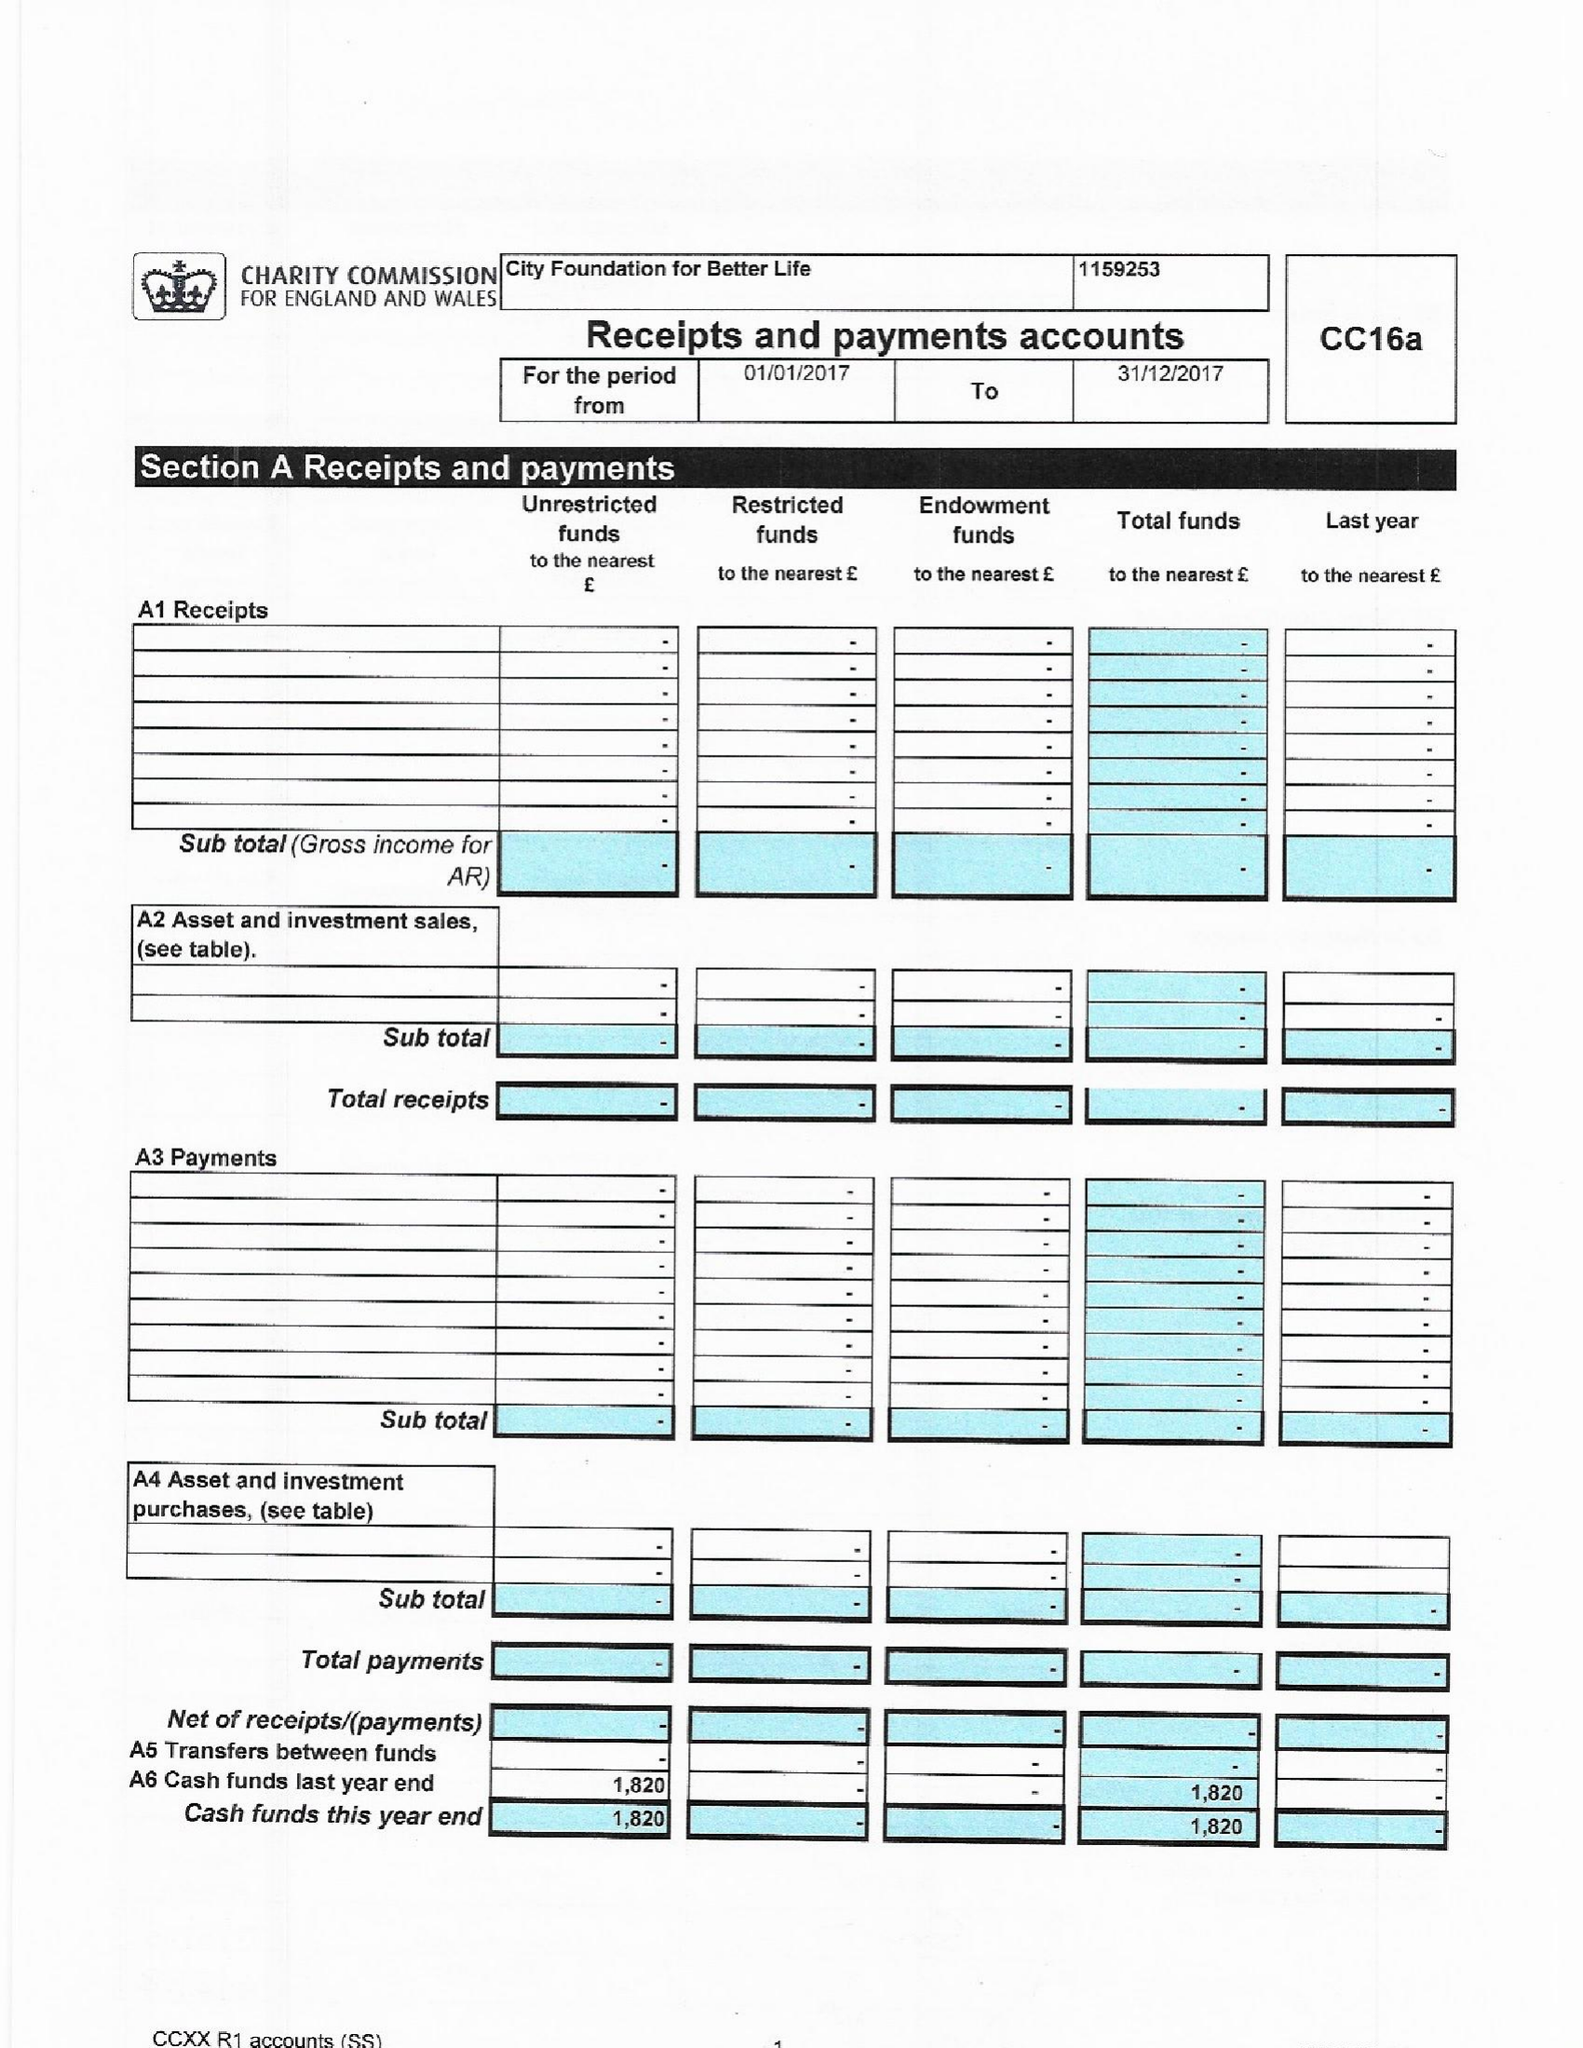What is the value for the report_date?
Answer the question using a single word or phrase. 2017-12-31 